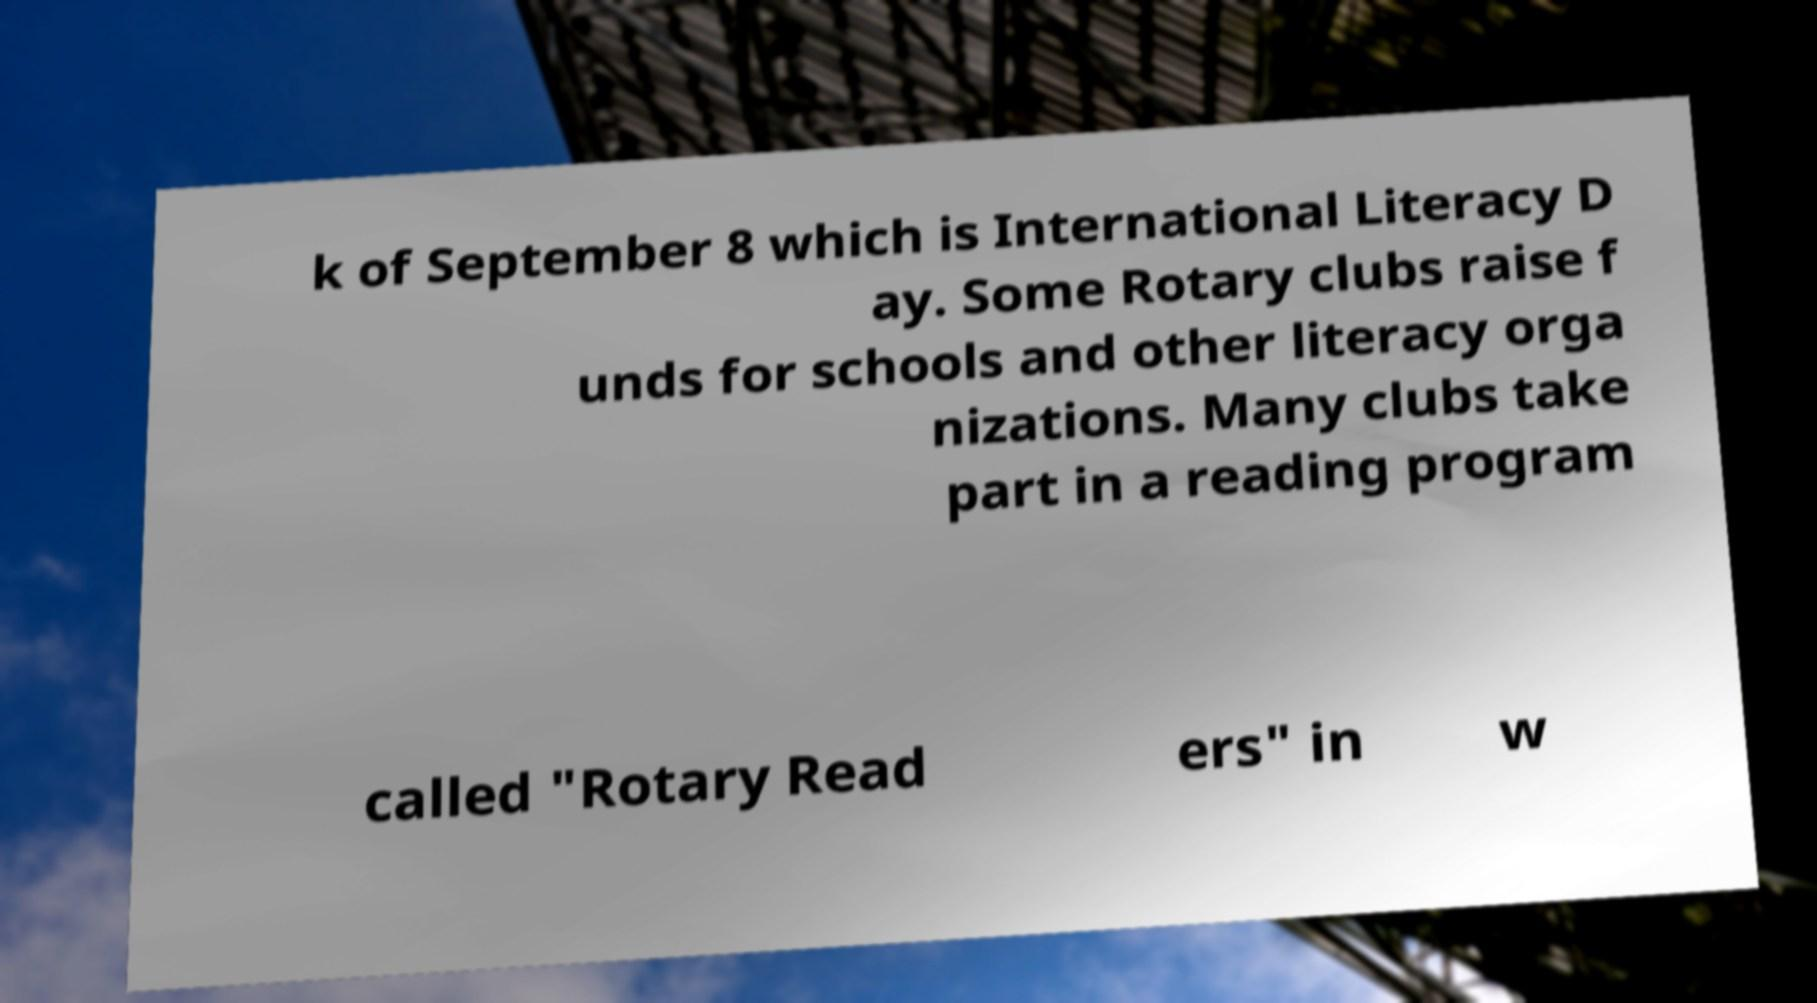I need the written content from this picture converted into text. Can you do that? k of September 8 which is International Literacy D ay. Some Rotary clubs raise f unds for schools and other literacy orga nizations. Many clubs take part in a reading program called "Rotary Read ers" in w 